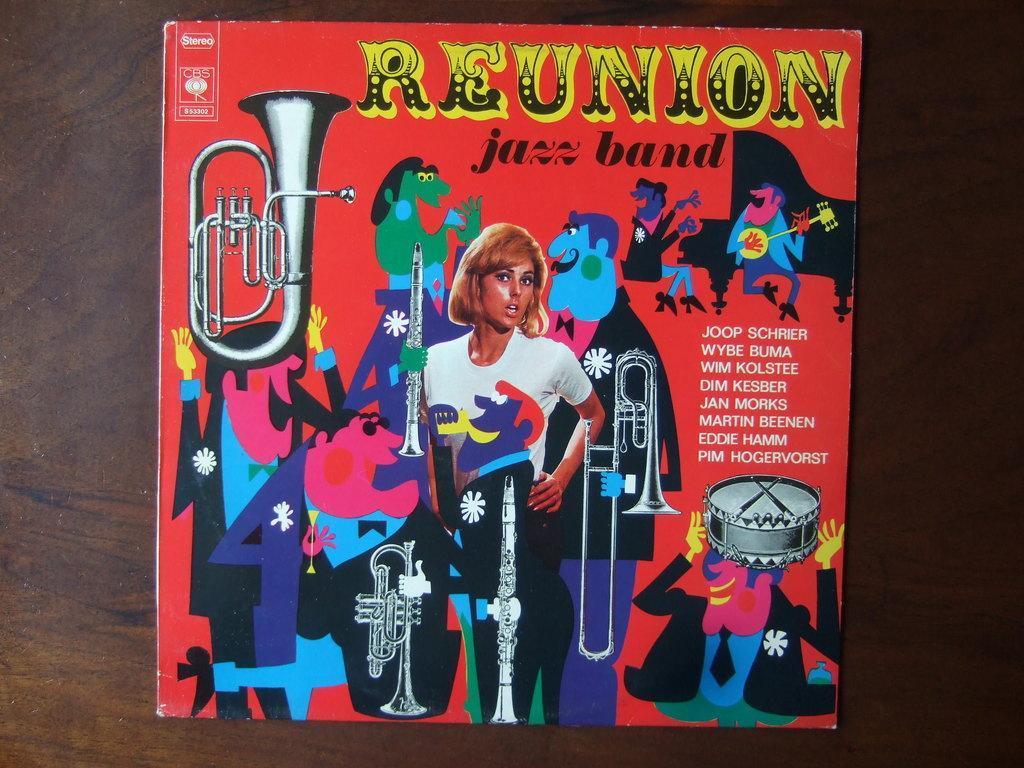Could you give a brief overview of what you see in this image? In this picture, we see a cardboard in red color containing the cartoons and the image of the woman is placed on the brown color wooden table. We even see the musical instruments and the text written on the red color board. 